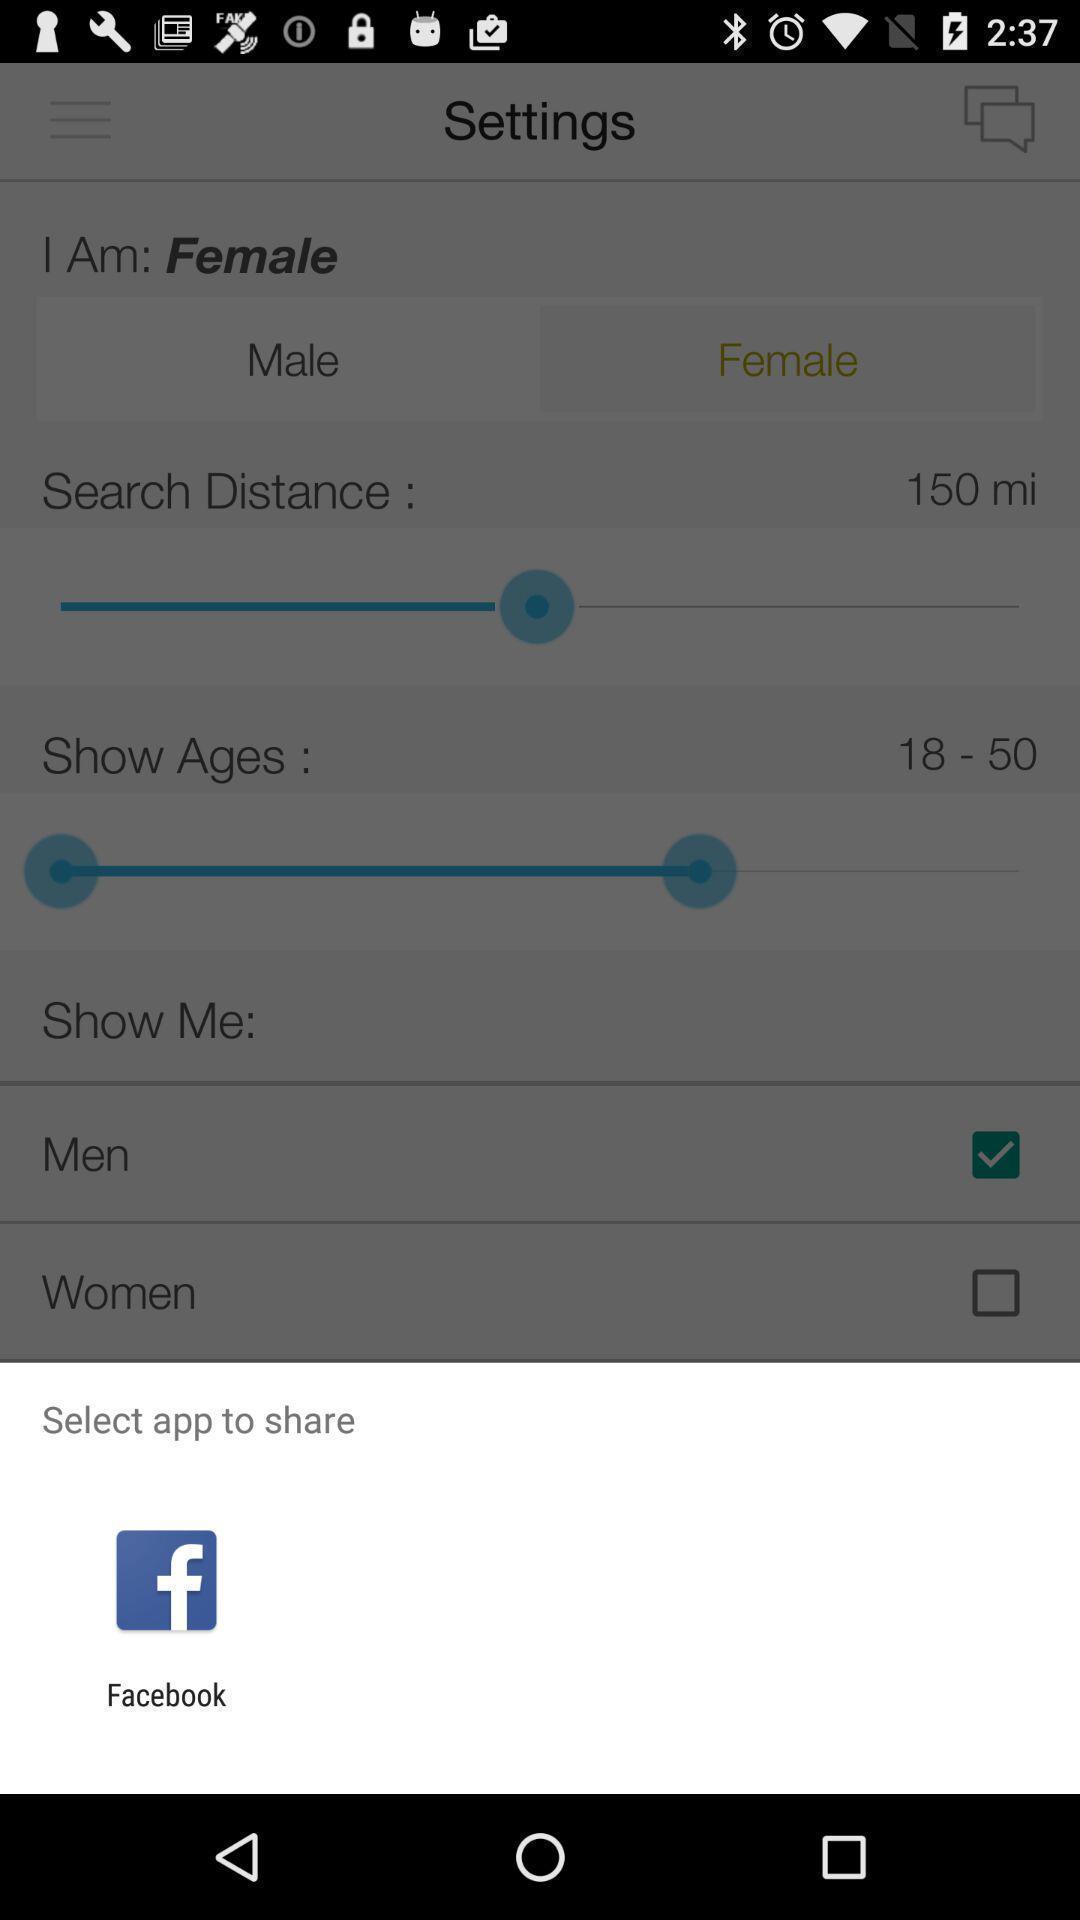Please provide a description for this image. Select a app to share settings. 